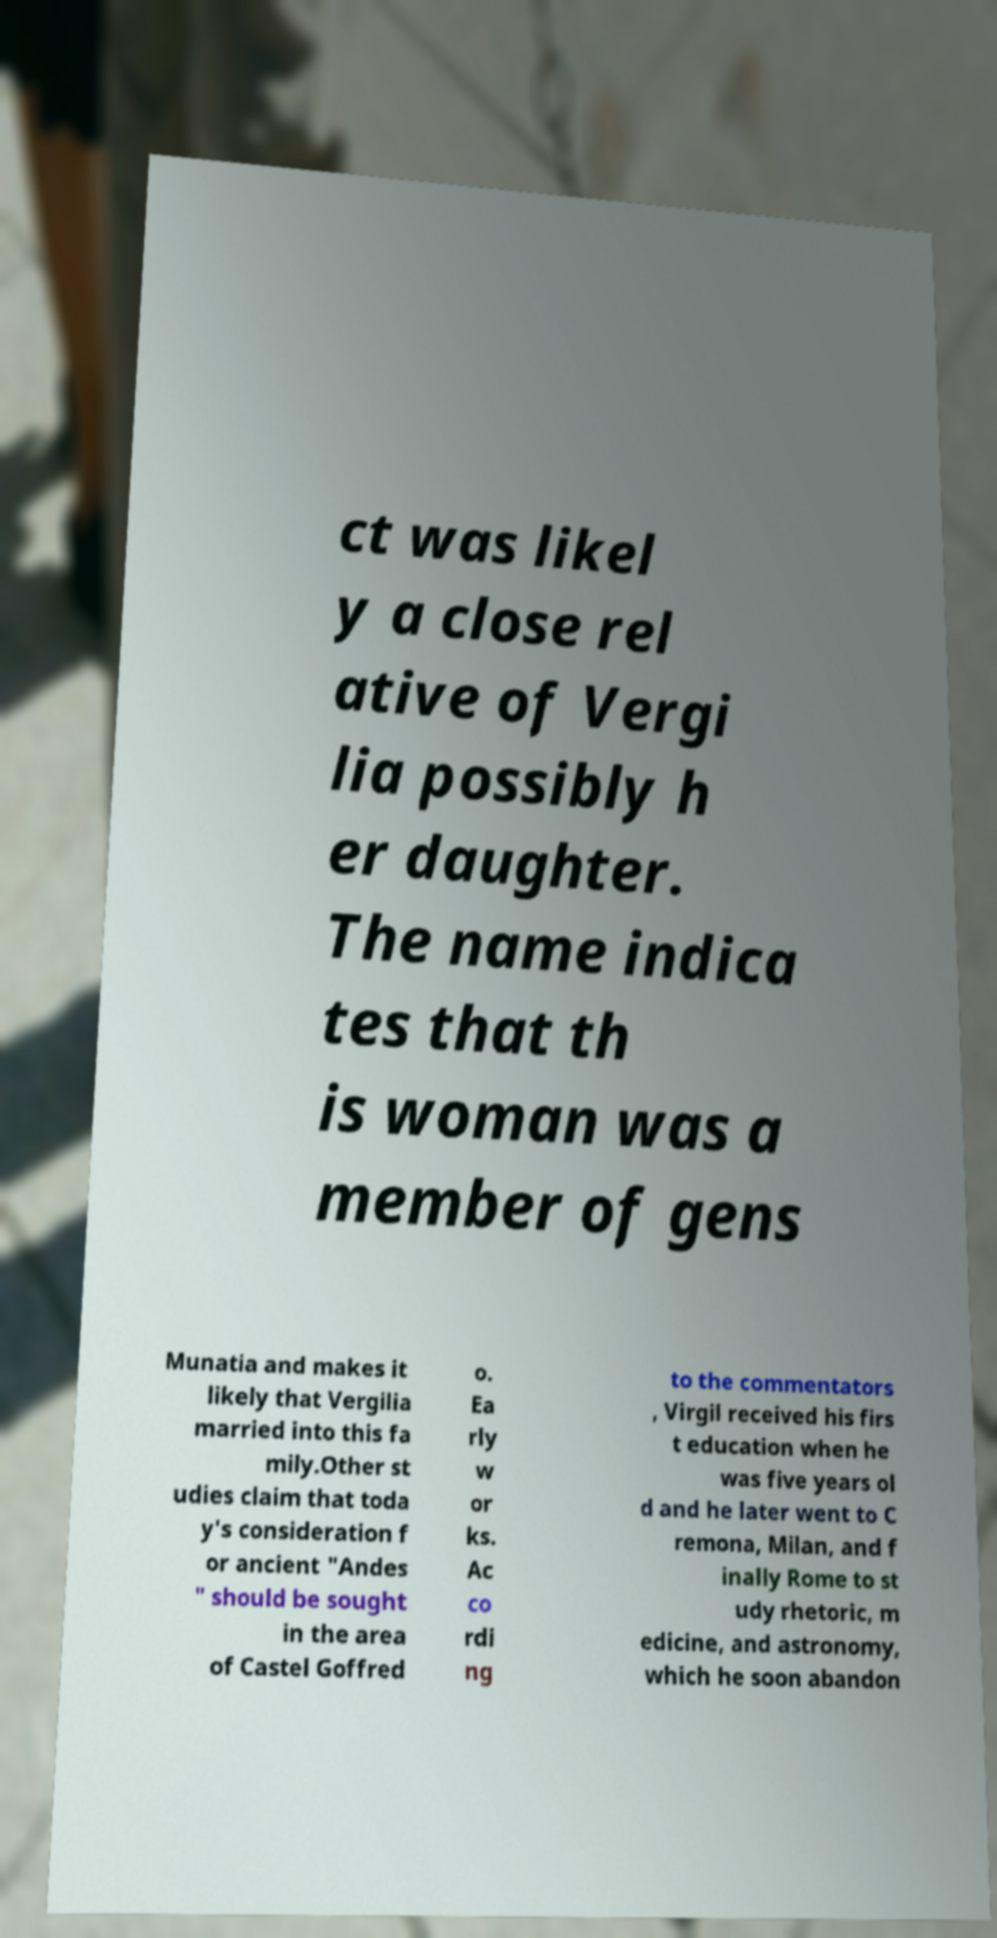Could you assist in decoding the text presented in this image and type it out clearly? ct was likel y a close rel ative of Vergi lia possibly h er daughter. The name indica tes that th is woman was a member of gens Munatia and makes it likely that Vergilia married into this fa mily.Other st udies claim that toda y's consideration f or ancient "Andes " should be sought in the area of Castel Goffred o. Ea rly w or ks. Ac co rdi ng to the commentators , Virgil received his firs t education when he was five years ol d and he later went to C remona, Milan, and f inally Rome to st udy rhetoric, m edicine, and astronomy, which he soon abandon 